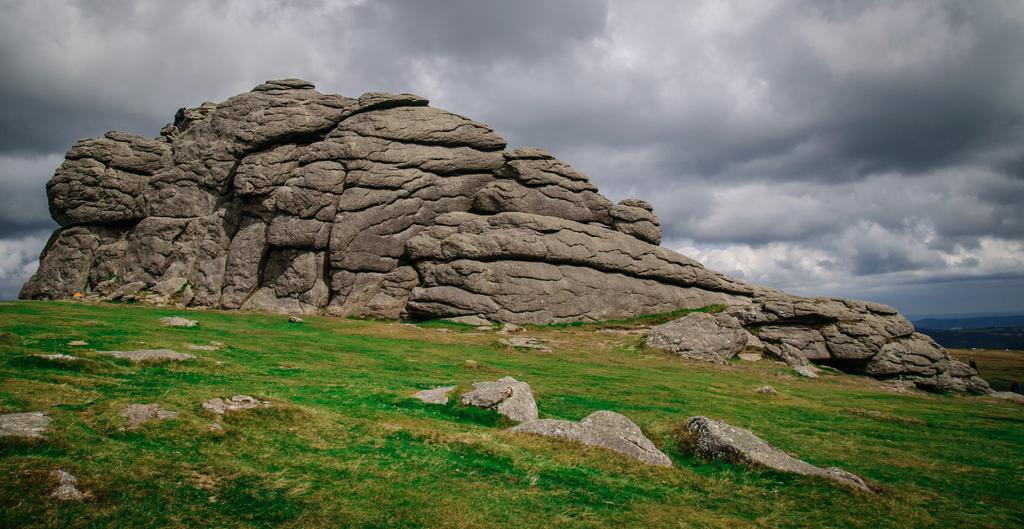Please provide a concise description of this image. This image consists of grass, rocks, mountains and the sky. This image is taken, may be during a day. 